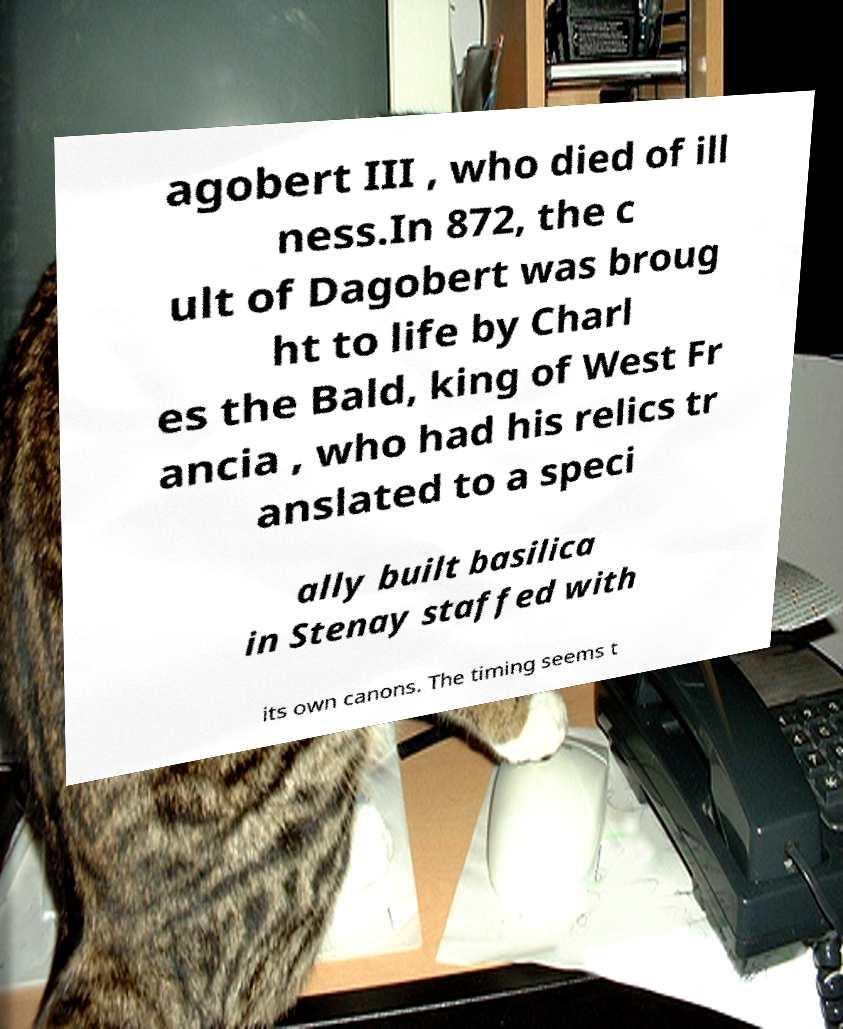Can you read and provide the text displayed in the image?This photo seems to have some interesting text. Can you extract and type it out for me? agobert III , who died of ill ness.In 872, the c ult of Dagobert was broug ht to life by Charl es the Bald, king of West Fr ancia , who had his relics tr anslated to a speci ally built basilica in Stenay staffed with its own canons. The timing seems t 